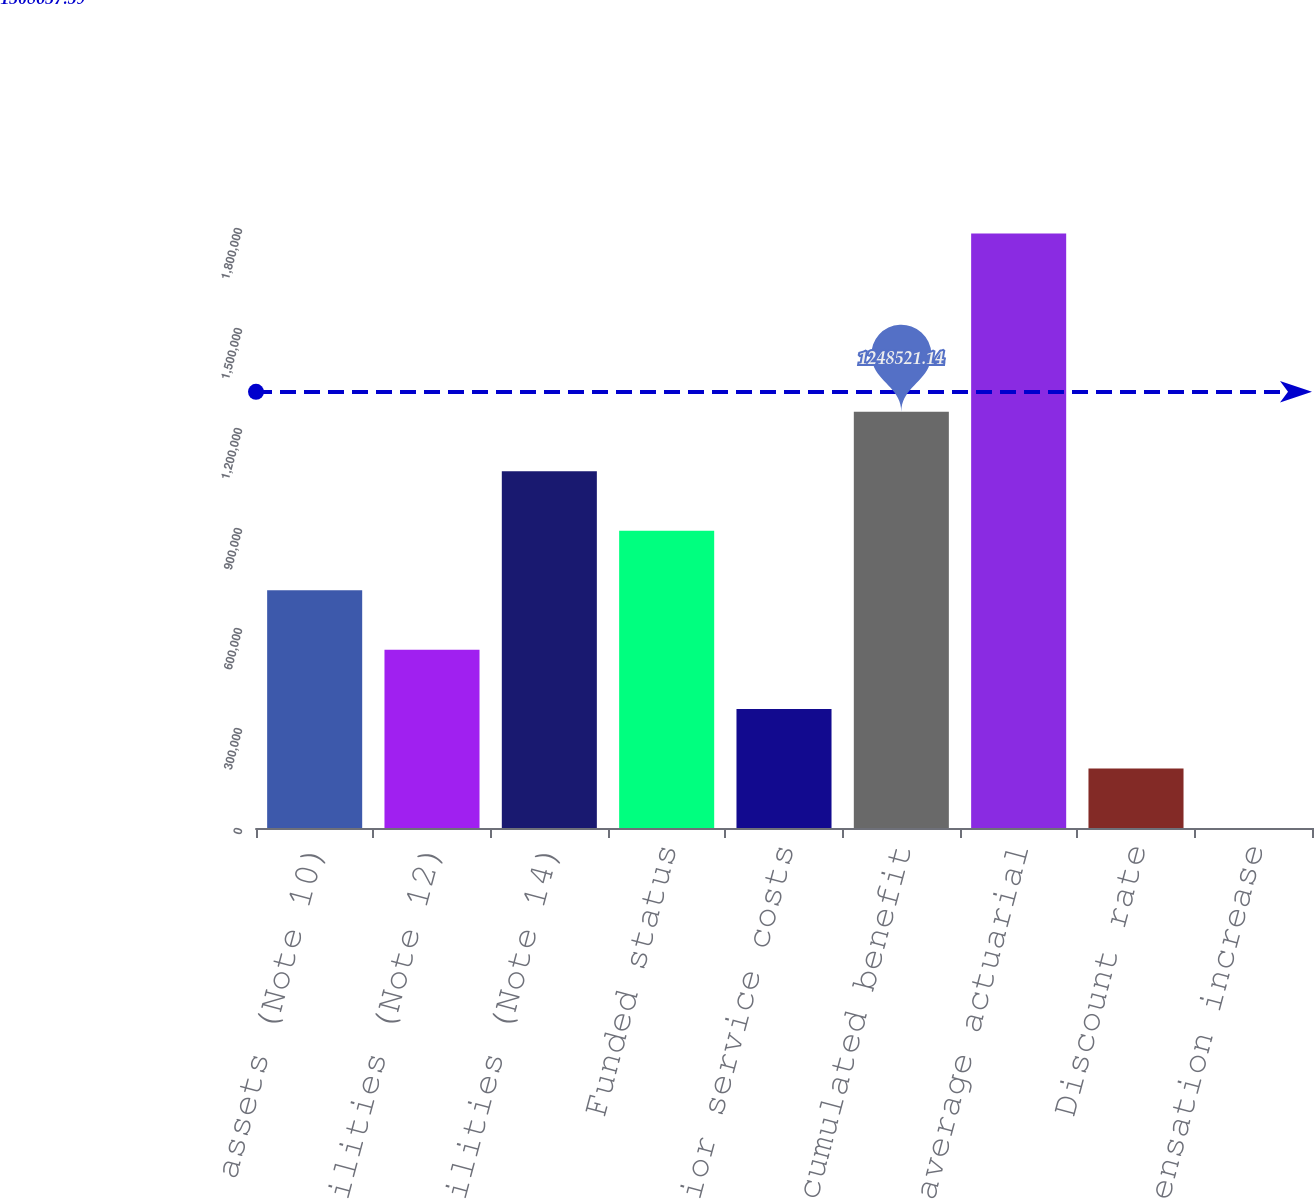Convert chart. <chart><loc_0><loc_0><loc_500><loc_500><bar_chart><fcel>Other assets (Note 10)<fcel>Accrued liabilities (Note 12)<fcel>Other liabilities (Note 14)<fcel>Funded status<fcel>Deferred prior service costs<fcel>Accumulated benefit<fcel>Weighted average actuarial<fcel>Discount rate<fcel>Rate of compensation increase<nl><fcel>713442<fcel>535083<fcel>1.07016e+06<fcel>891802<fcel>356723<fcel>1.24852e+06<fcel>1.7836e+06<fcel>178363<fcel>3.73<nl></chart> 